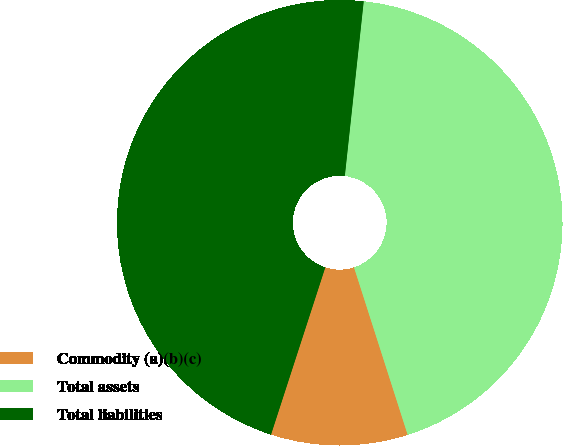<chart> <loc_0><loc_0><loc_500><loc_500><pie_chart><fcel>Commodity (a)(b)(c)<fcel>Total assets<fcel>Total liabilities<nl><fcel>9.93%<fcel>43.35%<fcel>46.72%<nl></chart> 